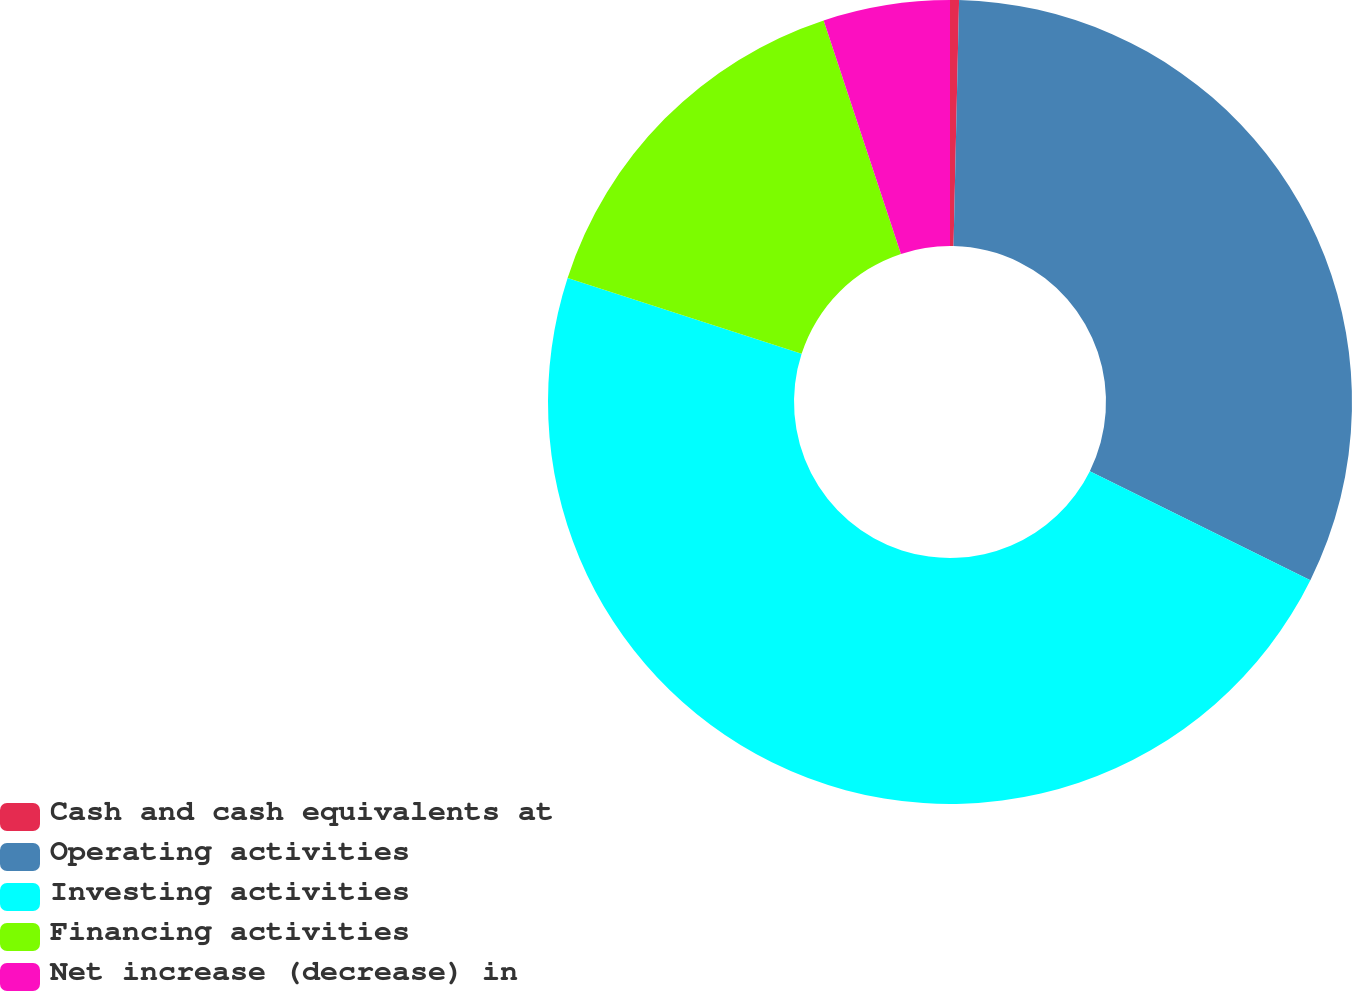Convert chart to OTSL. <chart><loc_0><loc_0><loc_500><loc_500><pie_chart><fcel>Cash and cash equivalents at<fcel>Operating activities<fcel>Investing activities<fcel>Financing activities<fcel>Net increase (decrease) in<nl><fcel>0.36%<fcel>31.95%<fcel>47.69%<fcel>14.92%<fcel>5.09%<nl></chart> 